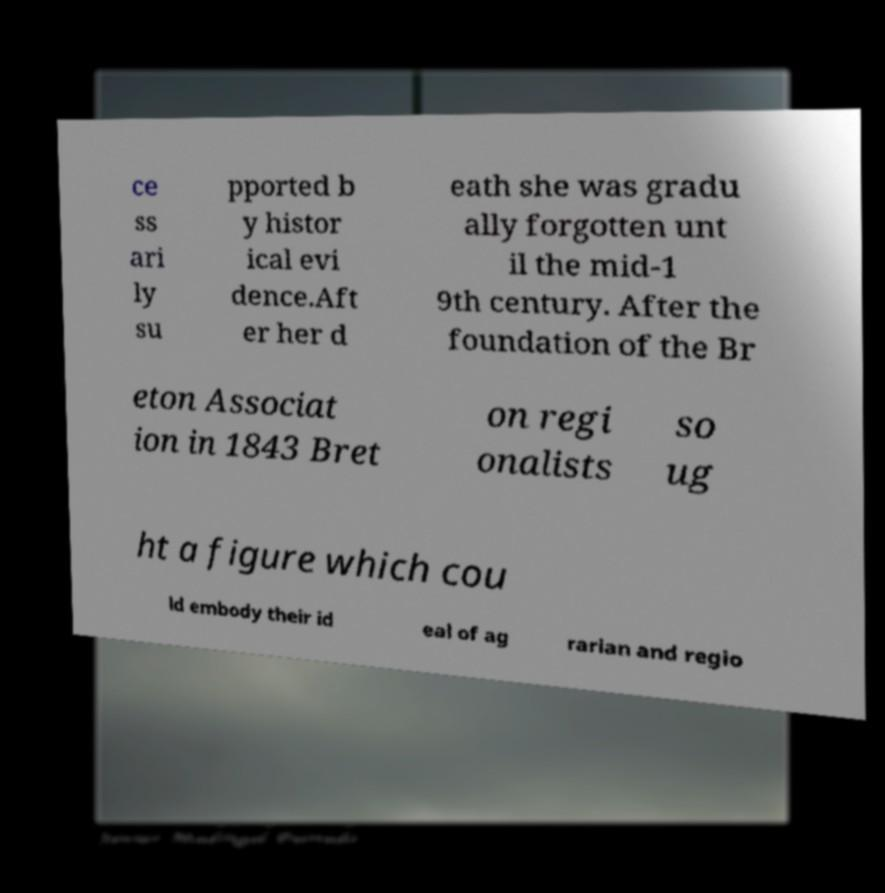Please identify and transcribe the text found in this image. ce ss ari ly su pported b y histor ical evi dence.Aft er her d eath she was gradu ally forgotten unt il the mid-1 9th century. After the foundation of the Br eton Associat ion in 1843 Bret on regi onalists so ug ht a figure which cou ld embody their id eal of ag rarian and regio 